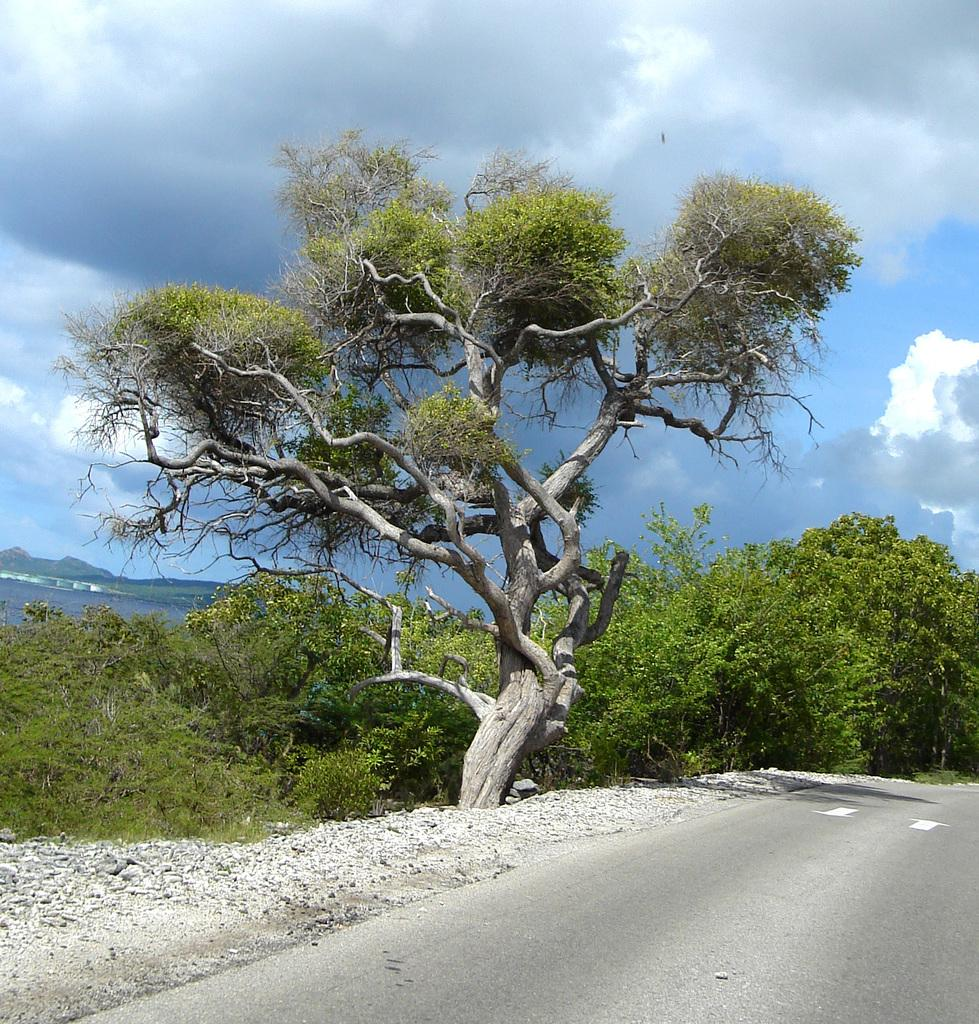What type of vegetation can be seen in the image? There are trees in the image. What natural element is visible besides the trees? There is water visible in the image. How would you describe the sky in the image? The sky is blue and cloudy. What type of plastic patch can be seen floating on the water in the image? There is no plastic patch visible in the image; only trees, water, and a blue, cloudy sky are present. 